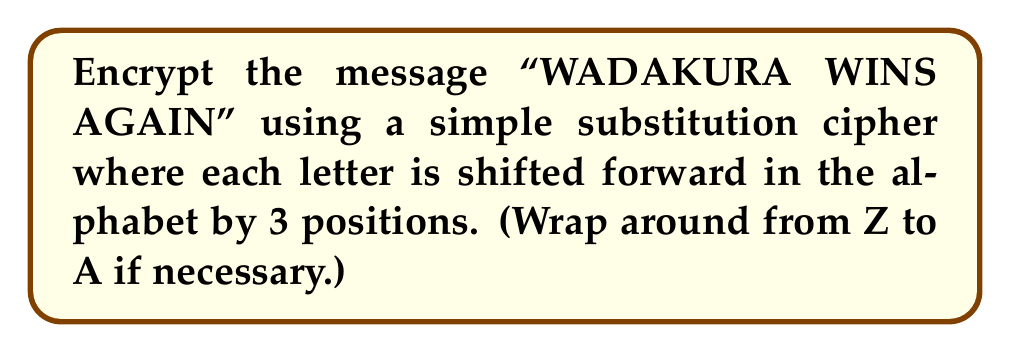Show me your answer to this math problem. To encrypt the message using a simple substitution cipher with a shift of 3, we follow these steps:

1. Write out the alphabet: 
   A B C D E F G H I J K L M N O P Q R S T U V W X Y Z

2. Shift each letter 3 positions forward:
   A → D, B → E, C → F, ..., X → A, Y → B, Z → C

3. Create a substitution table:
   A B C D E F G H I J K L M N O P Q R S T U V W X Y Z
   D E F G H I J K L M N O P Q R S T U V W X Y Z A B C

4. Encrypt each letter in the message:
   W → Z
   A → D
   D → G
   A → D
   K → N
   U → X
   R → U
   A → D

   W → Z
   I → L
   N → Q
   S → V

   A → D
   G → J
   A → D
   I → L
   N → Q

5. The encrypted message becomes:
   ZDGDNXUD ZLQV DJDLQ
Answer: ZDGDNXUD ZLQV DJDLQ 